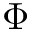<formula> <loc_0><loc_0><loc_500><loc_500>\Phi</formula> 